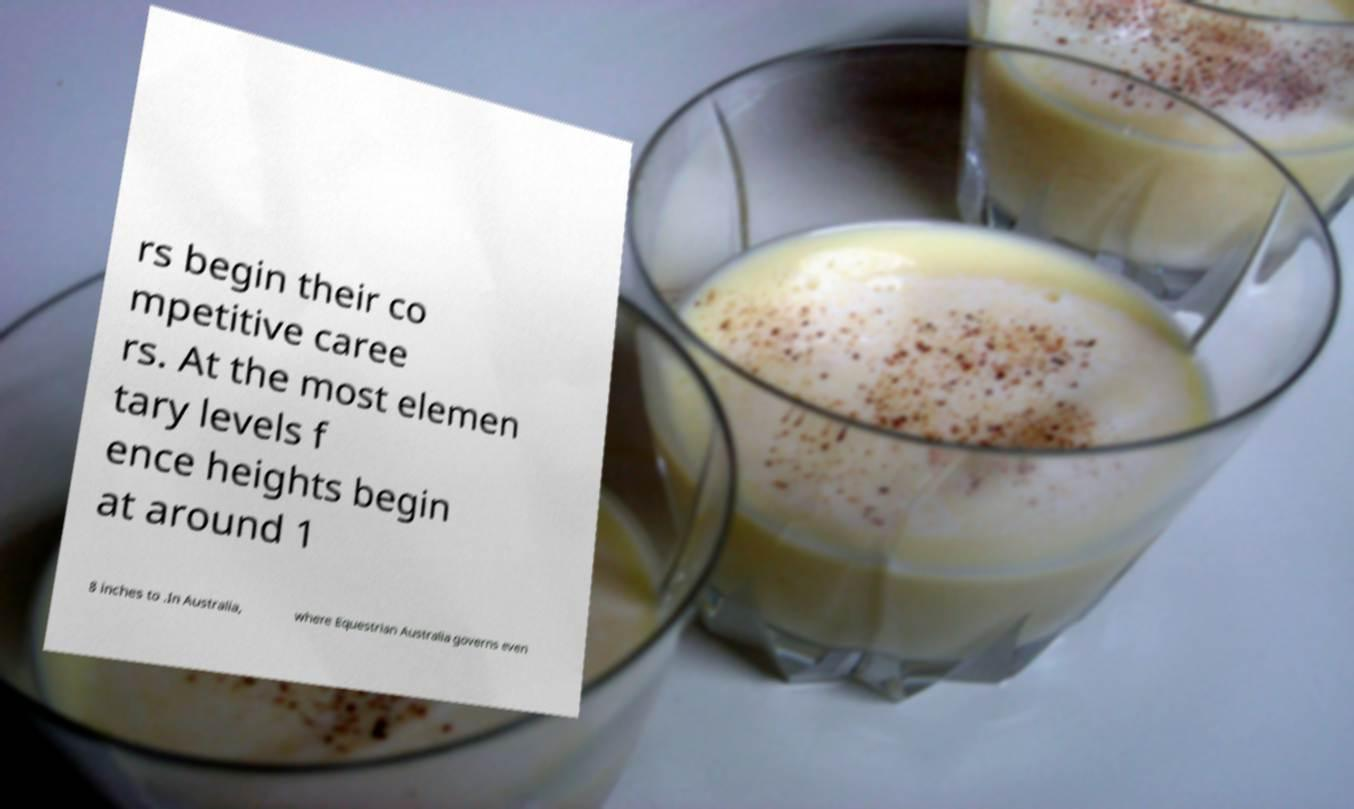For documentation purposes, I need the text within this image transcribed. Could you provide that? rs begin their co mpetitive caree rs. At the most elemen tary levels f ence heights begin at around 1 8 inches to .In Australia, where Equestrian Australia governs even 